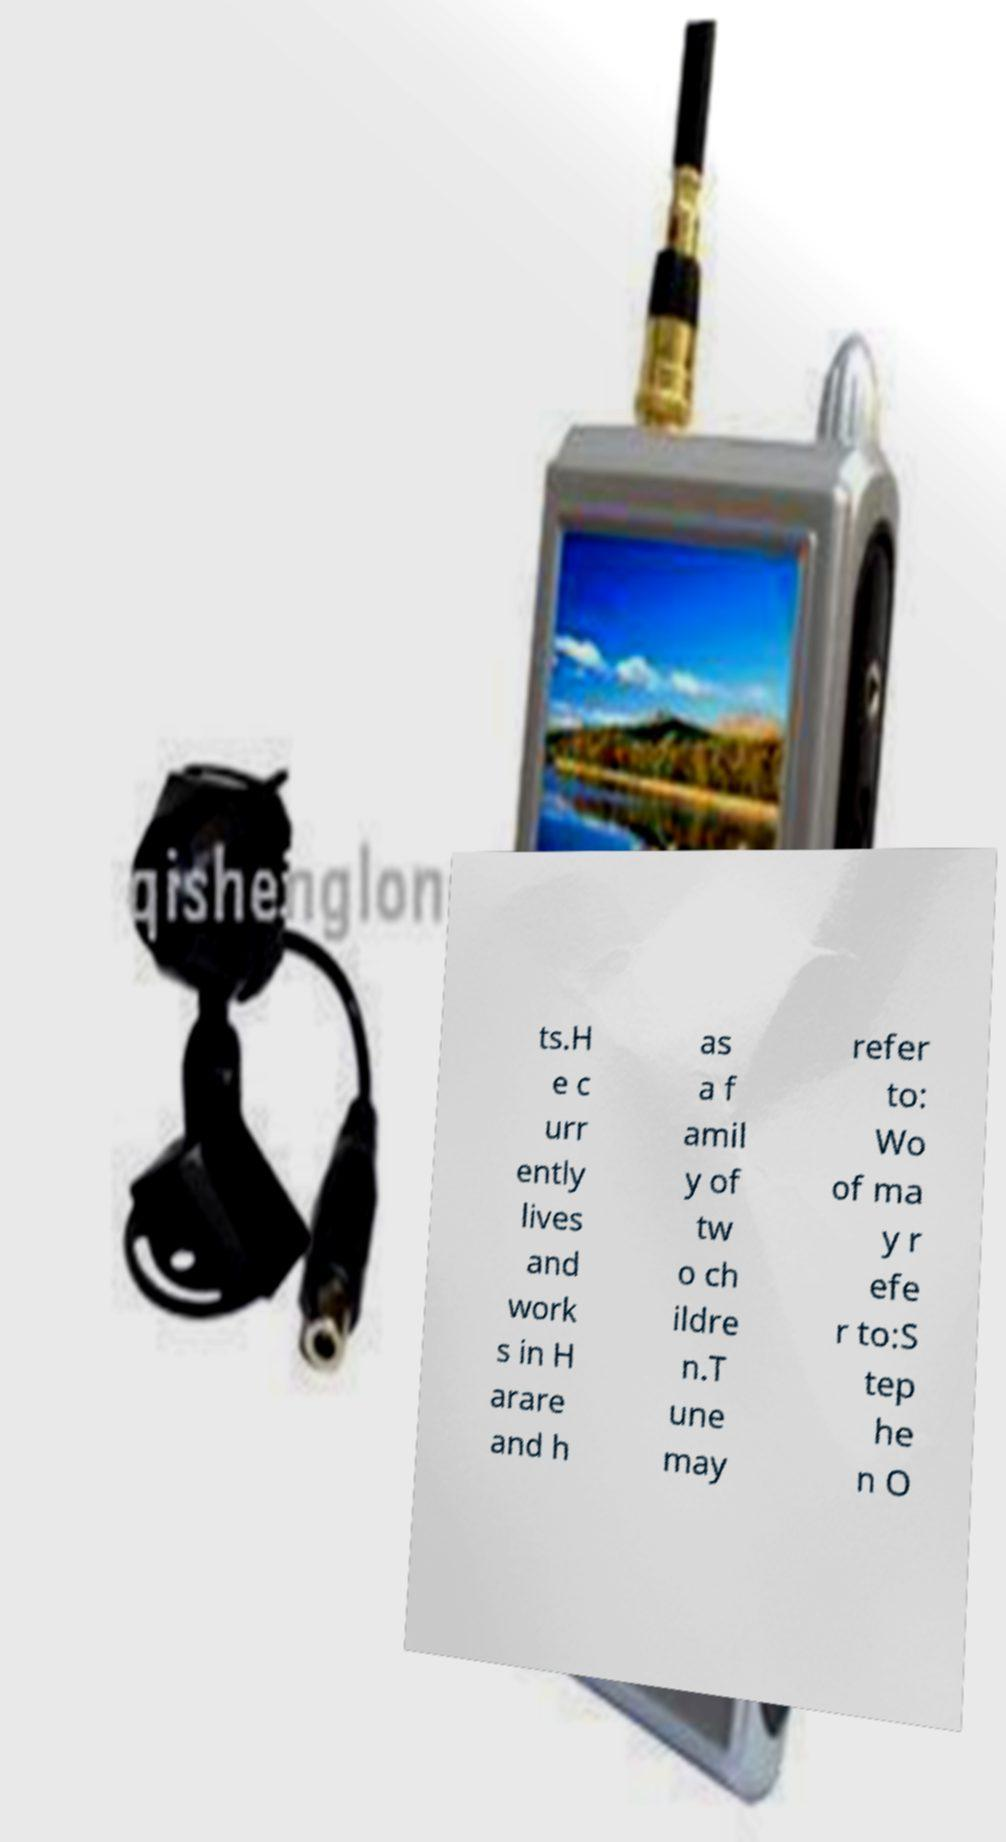What messages or text are displayed in this image? I need them in a readable, typed format. ts.H e c urr ently lives and work s in H arare and h as a f amil y of tw o ch ildre n.T une may refer to: Wo of ma y r efe r to:S tep he n O 